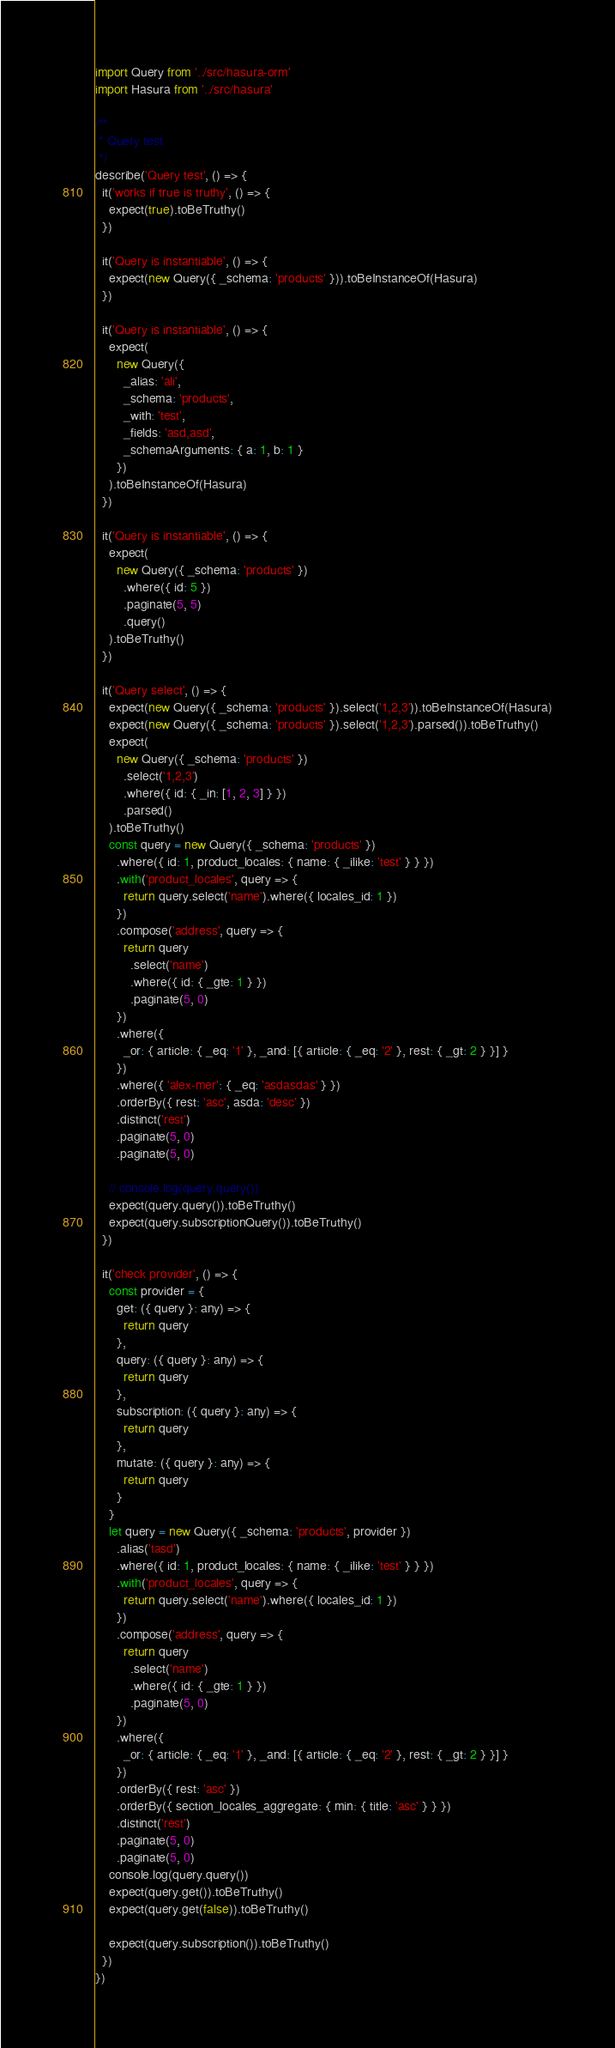Convert code to text. <code><loc_0><loc_0><loc_500><loc_500><_TypeScript_>import Query from '../src/hasura-orm'
import Hasura from '../src/hasura'

/**
 * Query test
 */
describe('Query test', () => {
  it('works if true is truthy', () => {
    expect(true).toBeTruthy()
  })

  it('Query is instantiable', () => {
    expect(new Query({ _schema: 'products' })).toBeInstanceOf(Hasura)
  })

  it('Query is instantiable', () => {
    expect(
      new Query({
        _alias: 'ali',
        _schema: 'products',
        _with: 'test',
        _fields: 'asd,asd',
        _schemaArguments: { a: 1, b: 1 }
      })
    ).toBeInstanceOf(Hasura)
  })

  it('Query is instantiable', () => {
    expect(
      new Query({ _schema: 'products' })
        .where({ id: 5 })
        .paginate(5, 5)
        .query()
    ).toBeTruthy()
  })

  it('Query select', () => {
    expect(new Query({ _schema: 'products' }).select('1,2,3')).toBeInstanceOf(Hasura)
    expect(new Query({ _schema: 'products' }).select('1,2,3').parsed()).toBeTruthy()
    expect(
      new Query({ _schema: 'products' })
        .select('1,2,3')
        .where({ id: { _in: [1, 2, 3] } })
        .parsed()
    ).toBeTruthy()
    const query = new Query({ _schema: 'products' })
      .where({ id: 1, product_locales: { name: { _ilike: 'test' } } })
      .with('product_locales', query => {
        return query.select('name').where({ locales_id: 1 })
      })
      .compose('address', query => {
        return query
          .select('name')
          .where({ id: { _gte: 1 } })
          .paginate(5, 0)
      })
      .where({
        _or: { article: { _eq: '1' }, _and: [{ article: { _eq: '2' }, rest: { _gt: 2 } }] }
      })
      .where({ 'alex-mer': { _eq: 'asdasdas' } })
      .orderBy({ rest: 'asc', asda: 'desc' })
      .distinct('rest')
      .paginate(5, 0)
      .paginate(5, 0)

    // console.log(query.query())
    expect(query.query()).toBeTruthy()
    expect(query.subscriptionQuery()).toBeTruthy()
  })

  it('check provider', () => {
    const provider = {
      get: ({ query }: any) => {
        return query
      },
      query: ({ query }: any) => {
        return query
      },
      subscription: ({ query }: any) => {
        return query
      },
      mutate: ({ query }: any) => {
        return query
      }
    }
    let query = new Query({ _schema: 'products', provider })
      .alias('tasd')
      .where({ id: 1, product_locales: { name: { _ilike: 'test' } } })
      .with('product_locales', query => {
        return query.select('name').where({ locales_id: 1 })
      })
      .compose('address', query => {
        return query
          .select('name')
          .where({ id: { _gte: 1 } })
          .paginate(5, 0)
      })
      .where({
        _or: { article: { _eq: '1' }, _and: [{ article: { _eq: '2' }, rest: { _gt: 2 } }] }
      })
      .orderBy({ rest: 'asc' })
      .orderBy({ section_locales_aggregate: { min: { title: 'asc' } } })
      .distinct('rest')
      .paginate(5, 0)
      .paginate(5, 0)
    console.log(query.query())
    expect(query.get()).toBeTruthy()
    expect(query.get(false)).toBeTruthy()

    expect(query.subscription()).toBeTruthy()
  })
})
</code> 